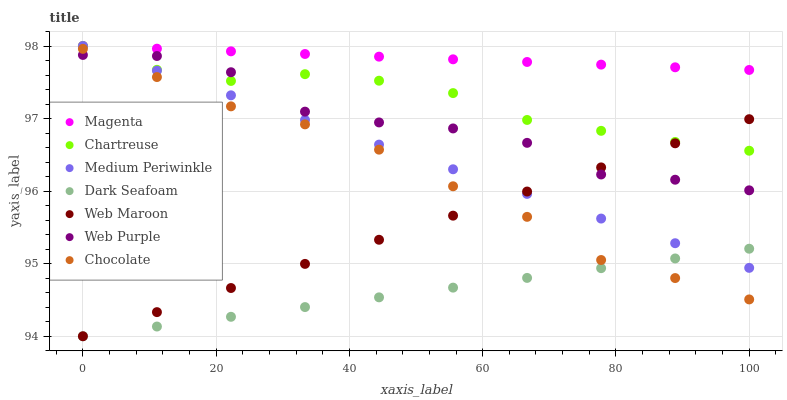Does Dark Seafoam have the minimum area under the curve?
Answer yes or no. Yes. Does Magenta have the maximum area under the curve?
Answer yes or no. Yes. Does Web Maroon have the minimum area under the curve?
Answer yes or no. No. Does Web Maroon have the maximum area under the curve?
Answer yes or no. No. Is Dark Seafoam the smoothest?
Answer yes or no. Yes. Is Web Purple the roughest?
Answer yes or no. Yes. Is Web Maroon the smoothest?
Answer yes or no. No. Is Web Maroon the roughest?
Answer yes or no. No. Does Web Maroon have the lowest value?
Answer yes or no. Yes. Does Chartreuse have the lowest value?
Answer yes or no. No. Does Magenta have the highest value?
Answer yes or no. Yes. Does Web Maroon have the highest value?
Answer yes or no. No. Is Chocolate less than Magenta?
Answer yes or no. Yes. Is Medium Periwinkle greater than Chocolate?
Answer yes or no. Yes. Does Medium Periwinkle intersect Magenta?
Answer yes or no. Yes. Is Medium Periwinkle less than Magenta?
Answer yes or no. No. Is Medium Periwinkle greater than Magenta?
Answer yes or no. No. Does Chocolate intersect Magenta?
Answer yes or no. No. 